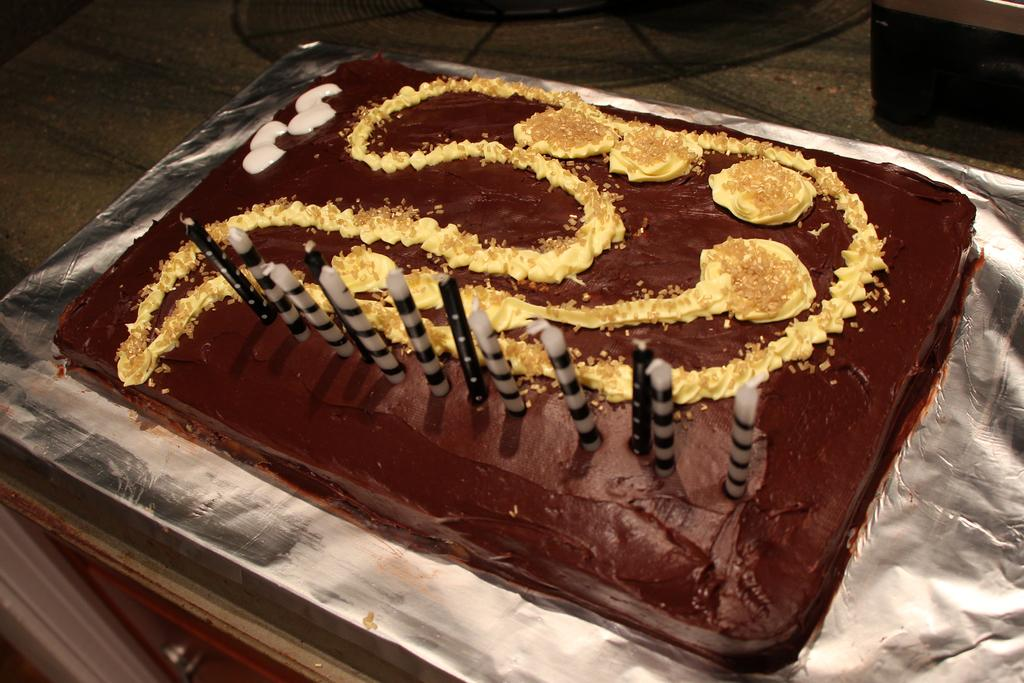What is on top of the cake in the image? There is a group of candles on the cake. What is the cake placed on? The cake is placed on foil. What can be seen in the background of the image? There is a table in the background of the image. How many clovers are hidden in the cake in the image? There are no clovers present in the image, as it features a cake with candles and not a clover-themed dessert. 